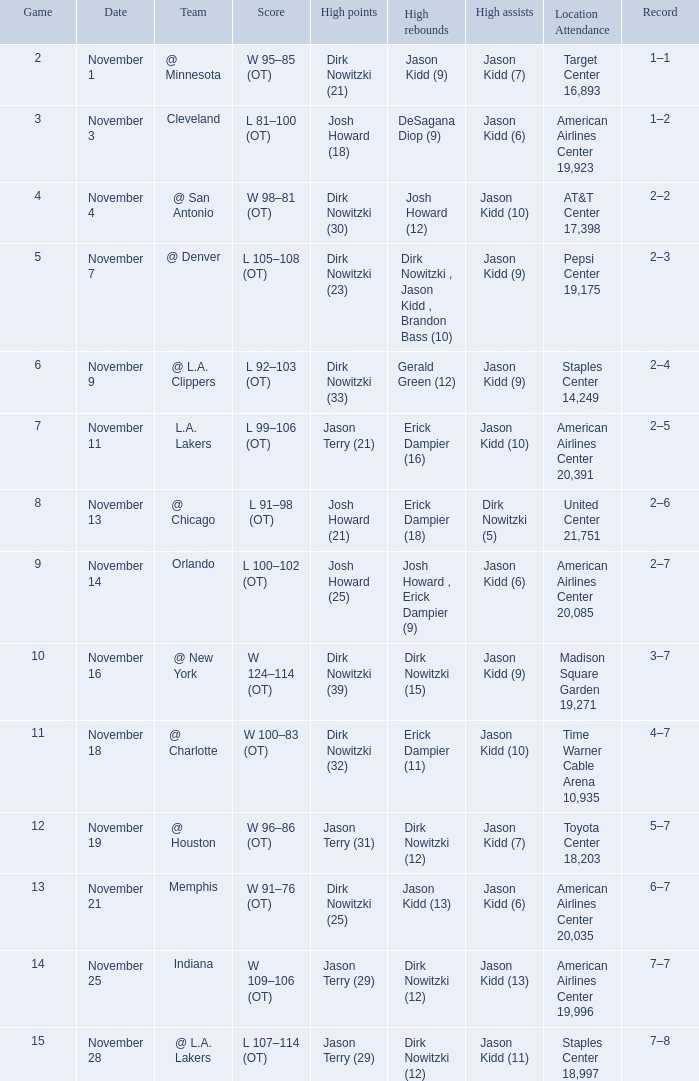On november 1, what was the record? 1–1. 